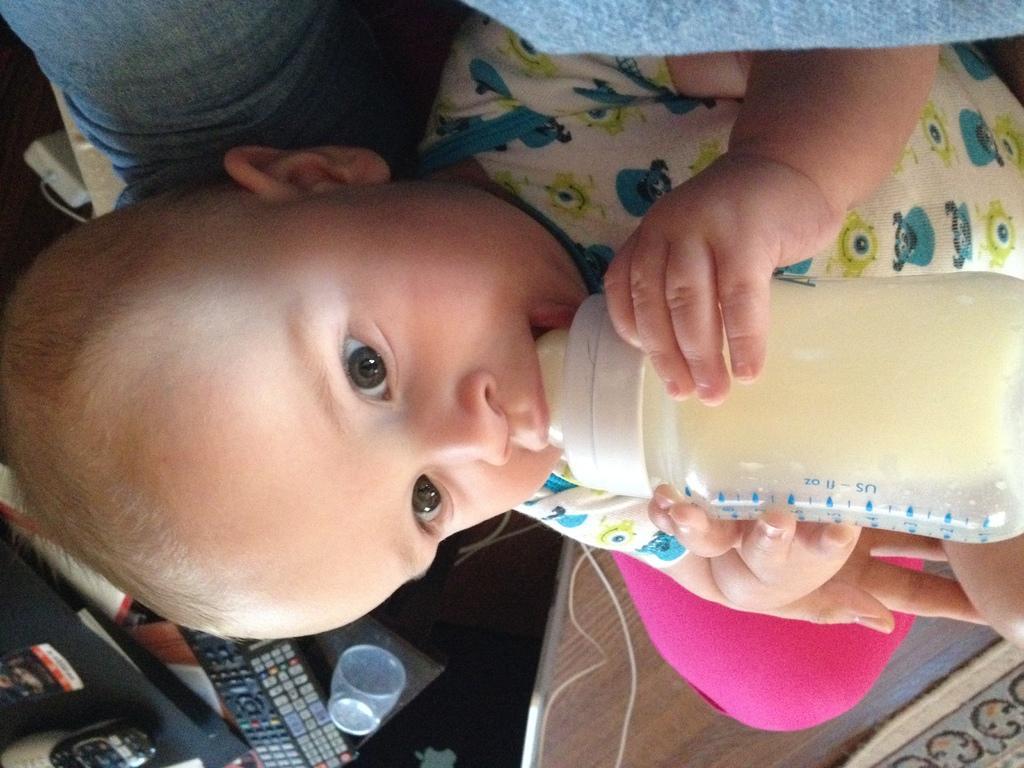Describe this image in one or two sentences. In this image there is a baby drinking the milk and the background there is a remote , glass in table. 